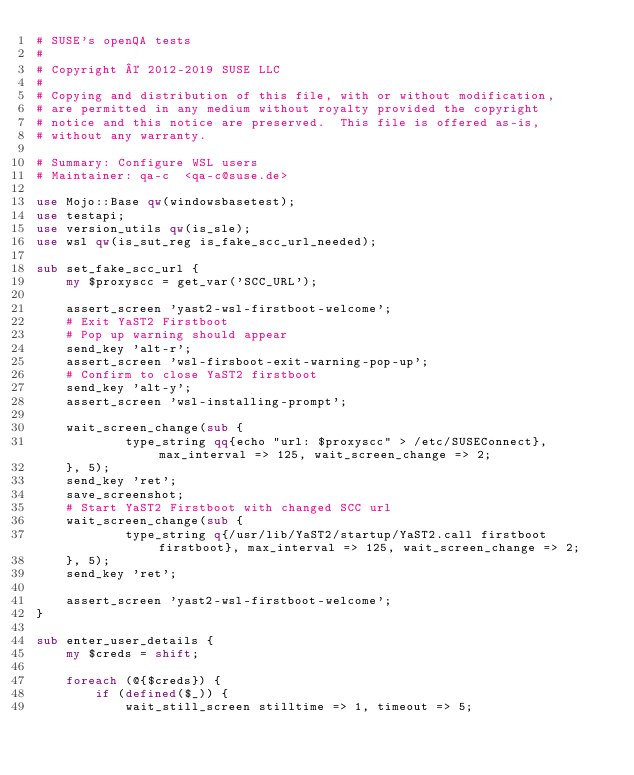<code> <loc_0><loc_0><loc_500><loc_500><_Perl_># SUSE's openQA tests
#
# Copyright © 2012-2019 SUSE LLC
#
# Copying and distribution of this file, with or without modification,
# are permitted in any medium without royalty provided the copyright
# notice and this notice are preserved.  This file is offered as-is,
# without any warranty.

# Summary: Configure WSL users
# Maintainer: qa-c  <qa-c@suse.de>

use Mojo::Base qw(windowsbasetest);
use testapi;
use version_utils qw(is_sle);
use wsl qw(is_sut_reg is_fake_scc_url_needed);

sub set_fake_scc_url {
    my $proxyscc = get_var('SCC_URL');

    assert_screen 'yast2-wsl-firstboot-welcome';
    # Exit YaST2 Firstboot
    # Pop up warning should appear
    send_key 'alt-r';
    assert_screen 'wsl-firsboot-exit-warning-pop-up';
    # Confirm to close YaST2 firstboot
    send_key 'alt-y';
    assert_screen 'wsl-installing-prompt';

    wait_screen_change(sub {
            type_string qq{echo "url: $proxyscc" > /etc/SUSEConnect}, max_interval => 125, wait_screen_change => 2;
    }, 5);
    send_key 'ret';
    save_screenshot;
    # Start YaST2 Firstboot with changed SCC url
    wait_screen_change(sub {
            type_string q{/usr/lib/YaST2/startup/YaST2.call firstboot firstboot}, max_interval => 125, wait_screen_change => 2;
    }, 5);
    send_key 'ret';

    assert_screen 'yast2-wsl-firstboot-welcome';
}

sub enter_user_details {
    my $creds = shift;

    foreach (@{$creds}) {
        if (defined($_)) {
            wait_still_screen stilltime => 1, timeout => 5;</code> 